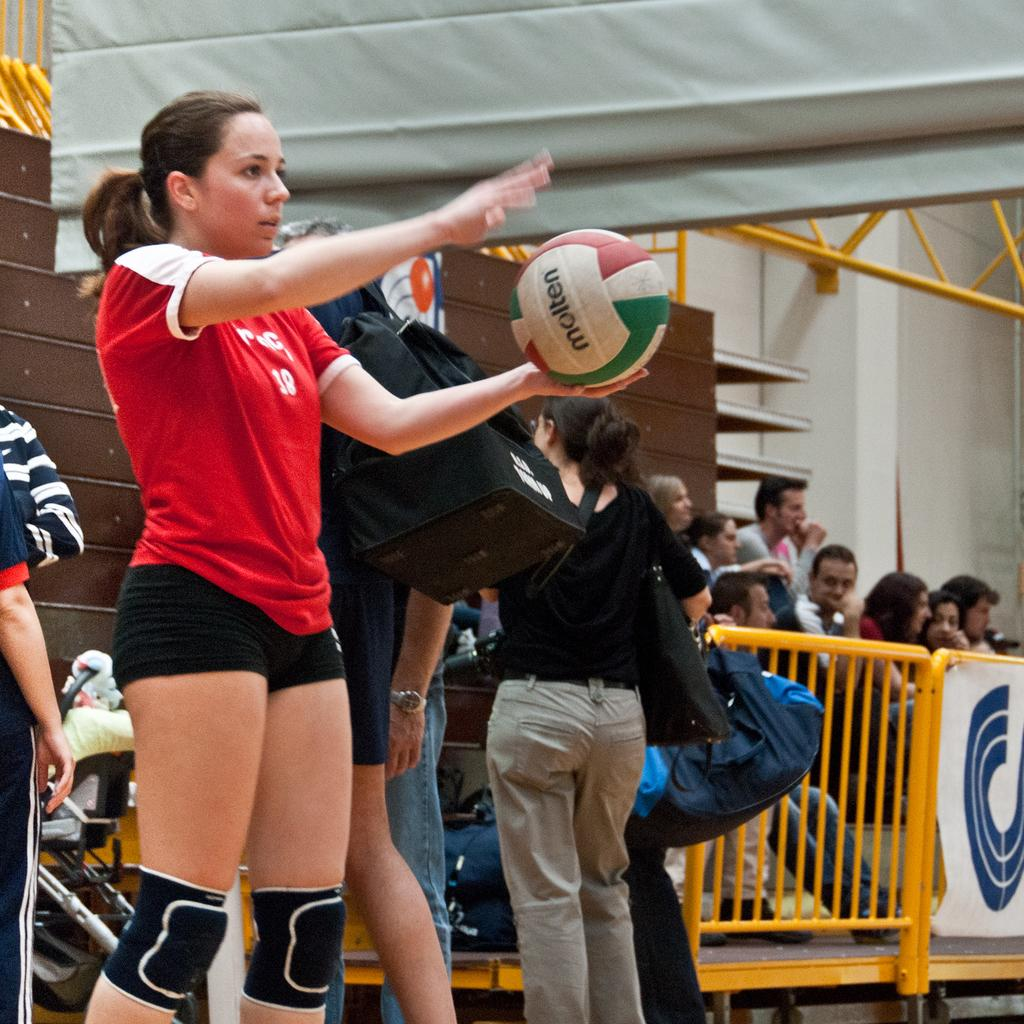Who is the main subject in the image? There is a woman in the image. What is the woman holding in the image? The woman is holding a ball. What can be seen in the background of the image? There are people standing in the background of the image. Can you describe the location of the people in the background? The people are near a railing. What statement does the ball make in the image? The ball is an inanimate object and cannot make statements. 